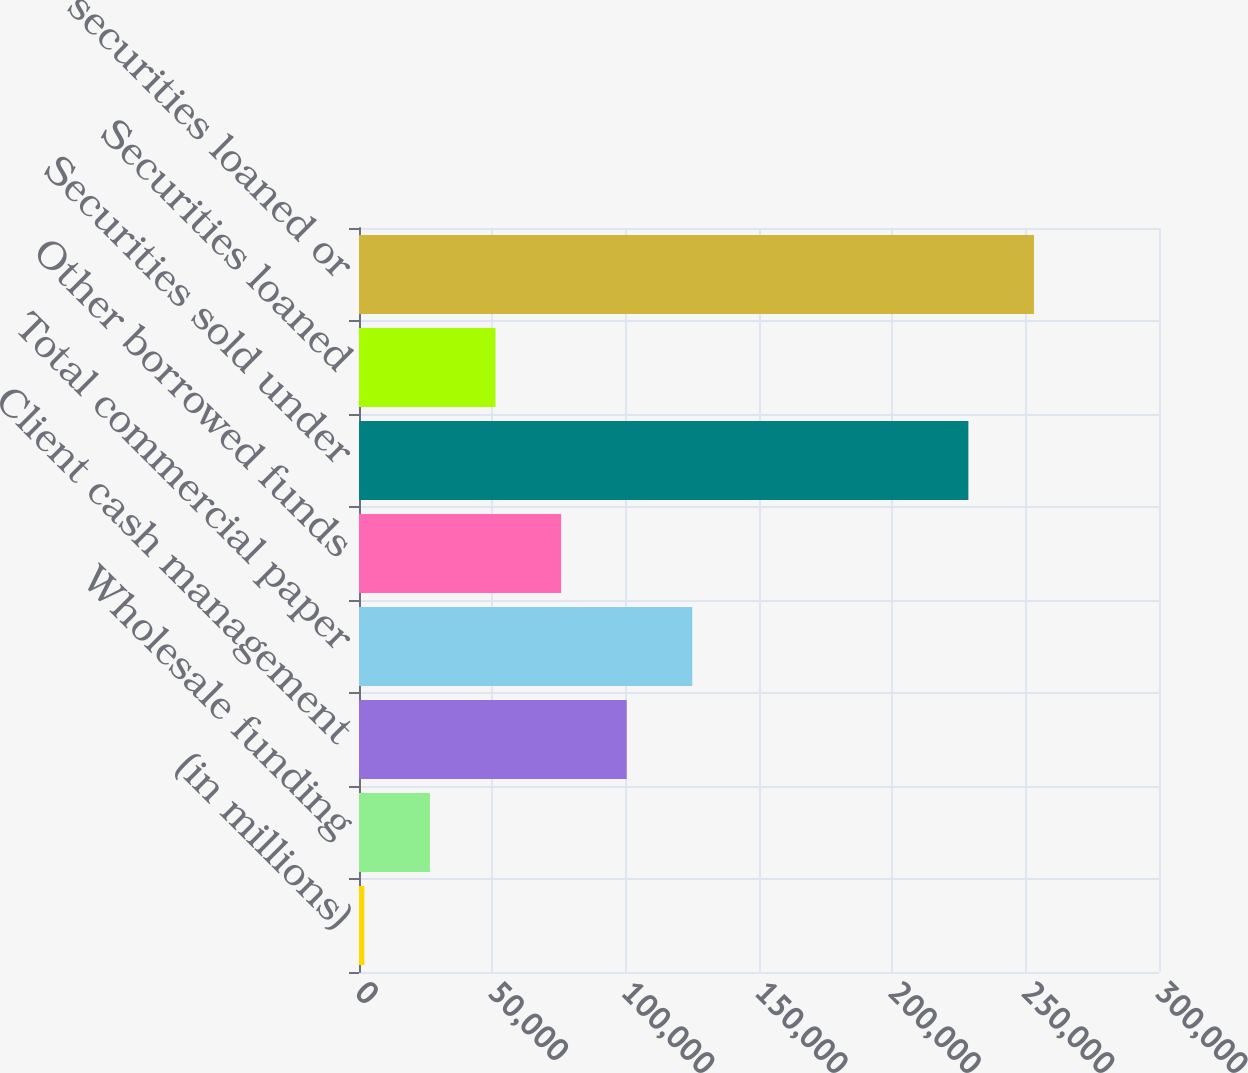<chart> <loc_0><loc_0><loc_500><loc_500><bar_chart><fcel>(in millions)<fcel>Wholesale funding<fcel>Client cash management<fcel>Total commercial paper<fcel>Other borrowed funds<fcel>Securities sold under<fcel>Securities loaned<fcel>Total securities loaned or<nl><fcel>2011<fcel>26605.1<fcel>100387<fcel>124982<fcel>75793.3<fcel>228514<fcel>51199.2<fcel>253108<nl></chart> 